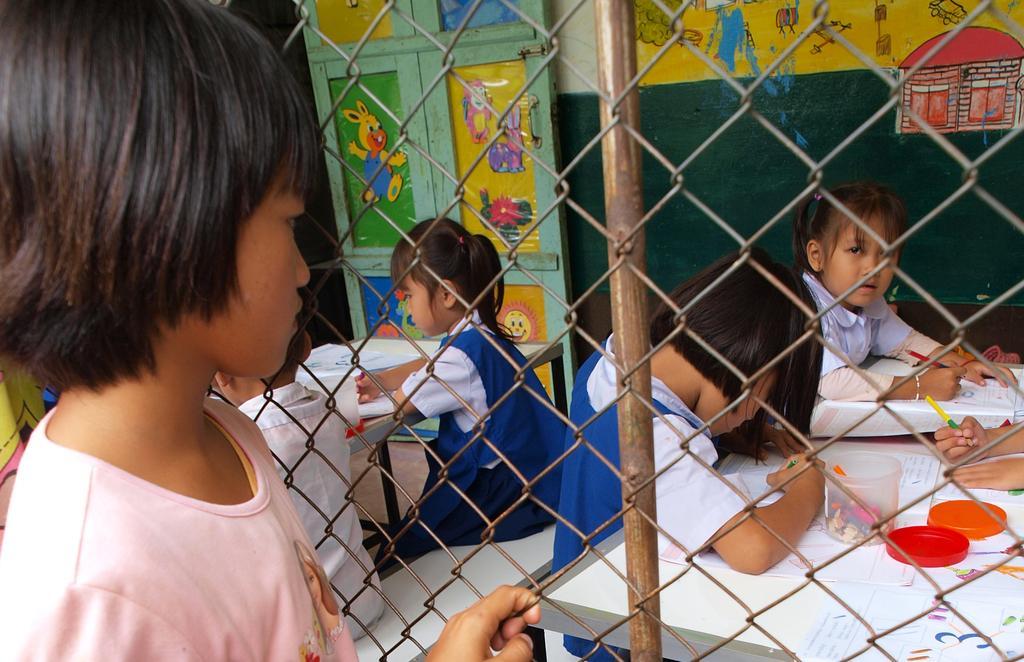In one or two sentences, can you explain what this image depicts? This image is taken indoors. On the left side of the image there is a girl. In the middle of the image there is a mesh. In the background there are two tables with many things on them and a few kids are sitting on the benches and writing on the papers and there is a wall with a few paintings on it and there is a door. 